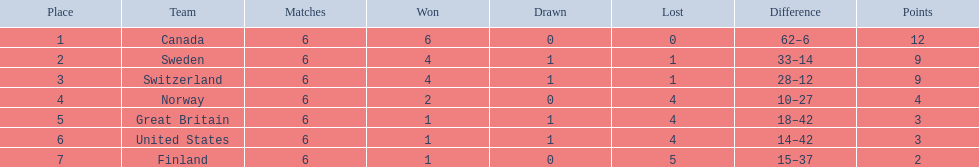What team placed after canada? Sweden. 